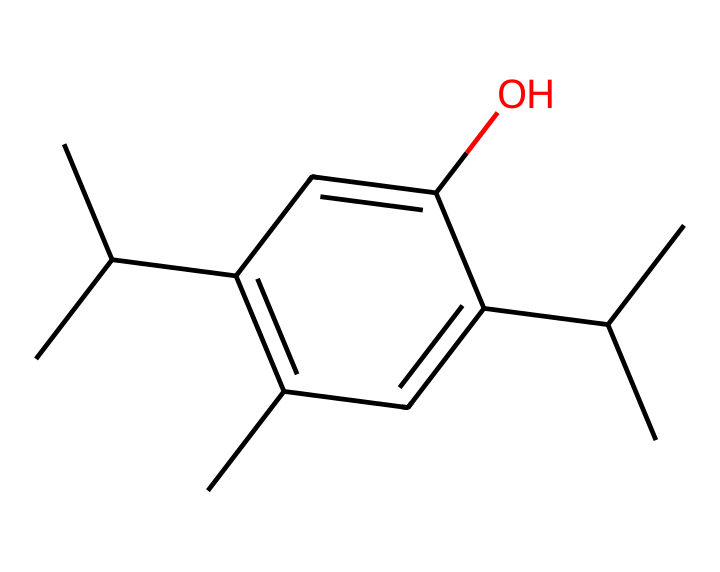What is the molecular formula of propofol? To determine the molecular formula from the SMILES representation, we count the number of each atom present. From the SMILES, there are 12 carbon (C) atoms, 18 hydrogen (H) atoms, and 1 oxygen (O) atom. Therefore, the molecular formula is C12H18O.
Answer: C12H18O How many hydroxyl (–OH) groups are present in propofol? In the chemical structure represented by the SMILES, there is one "O" in the structure and it connects with a hydrogen atom, indicating a hydroxyl group (–OH).
Answer: 1 What is the total number of rings in the chemical structure of propofol? The SMILES representation does not show any cyclic structures, as there are no '1' numbers indicating the start and end of a ring. Therefore, the total number of rings is zero.
Answer: 0 What type of drug is propofol commonly categorized as? Propofol is commonly categorized as an anesthetic due to its use in inducing and maintaining general anesthesia.
Answer: anesthetic Which functional group characterizes propofol's structure? Propofol contains a hydroxyl (-OH) functional group, indicated by the presence of the oxygen atom connected to hydrogen in the structure, which is characteristic of alcohols.
Answer: hydroxyl How many carbon atoms are branched in the propofol structure? In the SMILES representation, we can identify branching by examining the carbon structure. There are three branches of carbon chains, so we count those branches. The total number of branched carbon atoms is three.
Answer: 3 What is the saturation level of the carbon atoms in propofol? Given that all carbon atoms in this compound are single-bonded and the structure does not indicate any triple or double bonds, the carbon atoms are saturated. Therefore, the saturation level is saturated.
Answer: saturated 